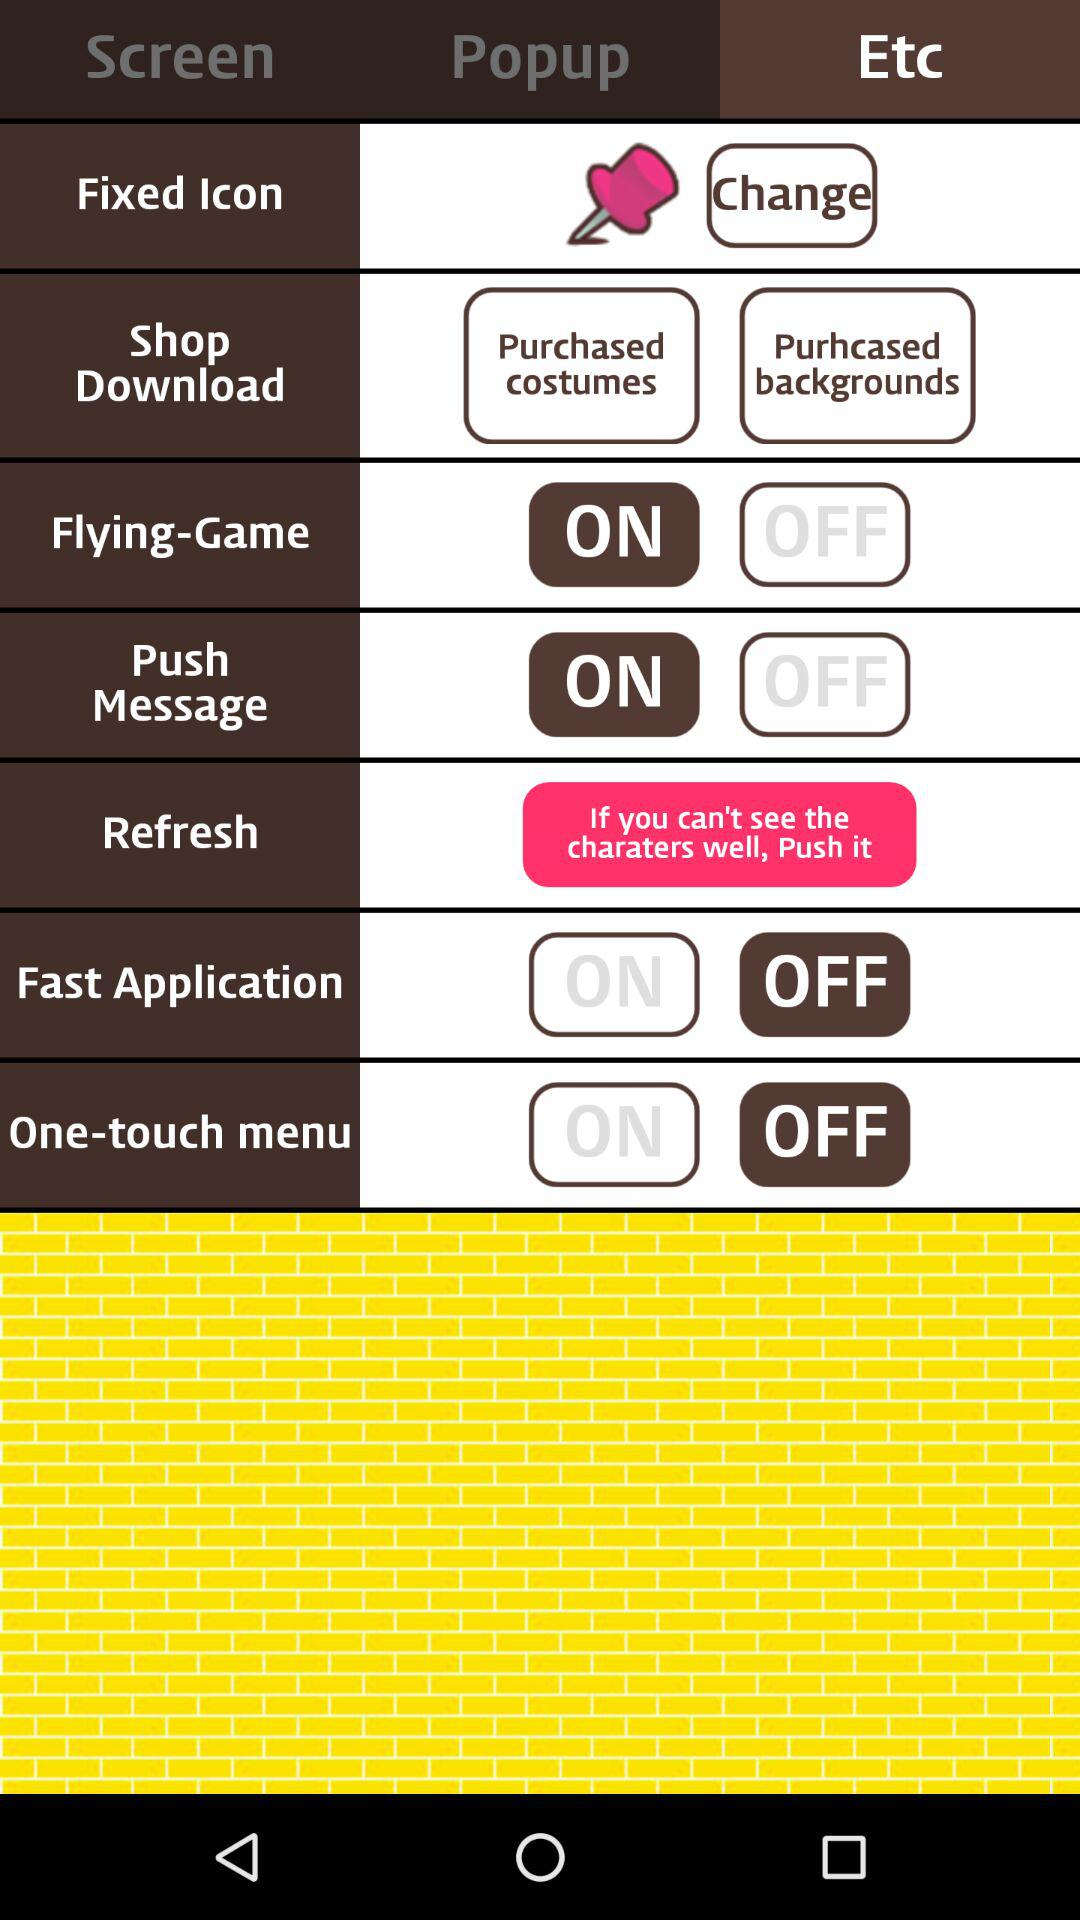Which options are available in "Popup"?
When the provided information is insufficient, respond with <no answer>. <no answer> 